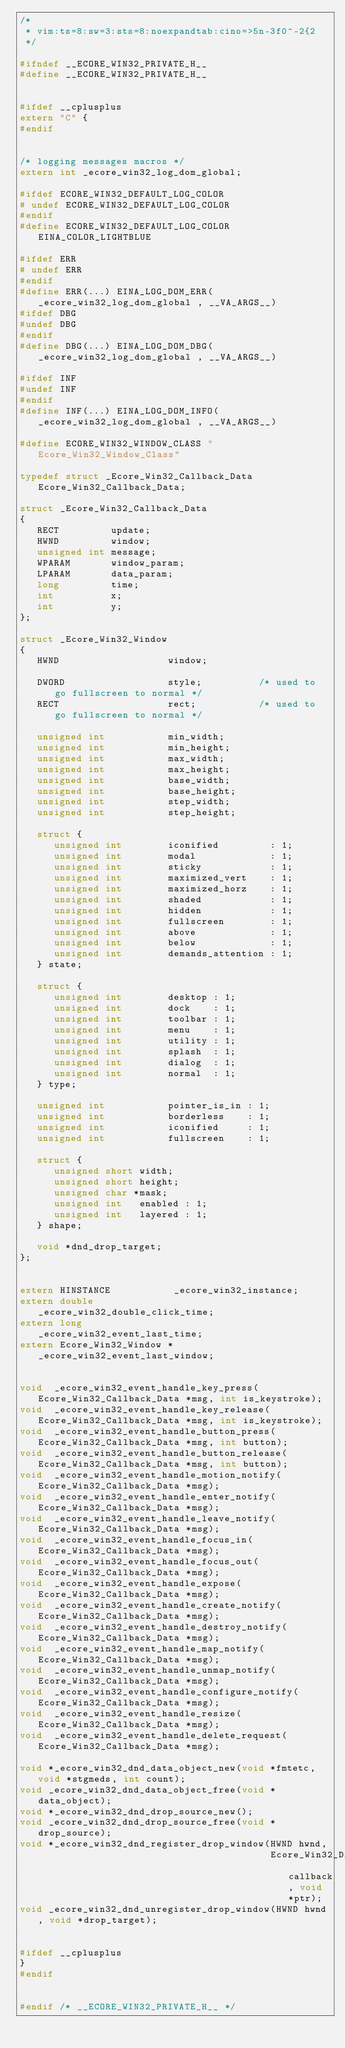<code> <loc_0><loc_0><loc_500><loc_500><_C_>/*
 * vim:ts=8:sw=3:sts=8:noexpandtab:cino=>5n-3f0^-2{2
 */

#ifndef __ECORE_WIN32_PRIVATE_H__
#define __ECORE_WIN32_PRIVATE_H__


#ifdef __cplusplus
extern "C" {
#endif


/* logging messages macros */
extern int _ecore_win32_log_dom_global;

#ifdef ECORE_WIN32_DEFAULT_LOG_COLOR
# undef ECORE_WIN32_DEFAULT_LOG_COLOR
#endif
#define ECORE_WIN32_DEFAULT_LOG_COLOR EINA_COLOR_LIGHTBLUE

#ifdef ERR
# undef ERR
#endif
#define ERR(...) EINA_LOG_DOM_ERR(_ecore_win32_log_dom_global , __VA_ARGS__)
#ifdef DBG
#undef DBG
#endif
#define DBG(...) EINA_LOG_DOM_DBG(_ecore_win32_log_dom_global , __VA_ARGS__)

#ifdef INF
#undef INF
#endif
#define INF(...) EINA_LOG_DOM_INFO(_ecore_win32_log_dom_global , __VA_ARGS__)

#define ECORE_WIN32_WINDOW_CLASS "Ecore_Win32_Window_Class"

typedef struct _Ecore_Win32_Callback_Data Ecore_Win32_Callback_Data;

struct _Ecore_Win32_Callback_Data
{
   RECT         update;
   HWND         window;
   unsigned int message;
   WPARAM       window_param;
   LPARAM       data_param;
   long         time;
   int          x;
   int          y;
};

struct _Ecore_Win32_Window
{
   HWND                   window;

   DWORD                  style;          /* used to go fullscreen to normal */
   RECT                   rect;           /* used to go fullscreen to normal */

   unsigned int           min_width;
   unsigned int           min_height;
   unsigned int           max_width;
   unsigned int           max_height;
   unsigned int           base_width;
   unsigned int           base_height;
   unsigned int           step_width;
   unsigned int           step_height;

   struct {
      unsigned int        iconified         : 1;
      unsigned int        modal             : 1;
      unsigned int        sticky            : 1;
      unsigned int        maximized_vert    : 1;
      unsigned int        maximized_horz    : 1;
      unsigned int        shaded            : 1;
      unsigned int        hidden            : 1;
      unsigned int        fullscreen        : 1;
      unsigned int        above             : 1;
      unsigned int        below             : 1;
      unsigned int        demands_attention : 1;
   } state;

   struct {
      unsigned int        desktop : 1;
      unsigned int        dock    : 1;
      unsigned int        toolbar : 1;
      unsigned int        menu    : 1;
      unsigned int        utility : 1;
      unsigned int        splash  : 1;
      unsigned int        dialog  : 1;
      unsigned int        normal  : 1;
   } type;

   unsigned int           pointer_is_in : 1;
   unsigned int           borderless    : 1;
   unsigned int           iconified     : 1;
   unsigned int           fullscreen    : 1;

   struct {
      unsigned short width;
      unsigned short height;
      unsigned char *mask;
      unsigned int   enabled : 1;
      unsigned int   layered : 1;
   } shape;

   void *dnd_drop_target;
};


extern HINSTANCE           _ecore_win32_instance;
extern double              _ecore_win32_double_click_time;
extern long                _ecore_win32_event_last_time;
extern Ecore_Win32_Window *_ecore_win32_event_last_window;


void  _ecore_win32_event_handle_key_press(Ecore_Win32_Callback_Data *msg, int is_keystroke);
void  _ecore_win32_event_handle_key_release(Ecore_Win32_Callback_Data *msg, int is_keystroke);
void  _ecore_win32_event_handle_button_press(Ecore_Win32_Callback_Data *msg, int button);
void  _ecore_win32_event_handle_button_release(Ecore_Win32_Callback_Data *msg, int button);
void  _ecore_win32_event_handle_motion_notify(Ecore_Win32_Callback_Data *msg);
void  _ecore_win32_event_handle_enter_notify(Ecore_Win32_Callback_Data *msg);
void  _ecore_win32_event_handle_leave_notify(Ecore_Win32_Callback_Data *msg);
void  _ecore_win32_event_handle_focus_in(Ecore_Win32_Callback_Data *msg);
void  _ecore_win32_event_handle_focus_out(Ecore_Win32_Callback_Data *msg);
void  _ecore_win32_event_handle_expose(Ecore_Win32_Callback_Data *msg);
void  _ecore_win32_event_handle_create_notify(Ecore_Win32_Callback_Data *msg);
void  _ecore_win32_event_handle_destroy_notify(Ecore_Win32_Callback_Data *msg);
void  _ecore_win32_event_handle_map_notify(Ecore_Win32_Callback_Data *msg);
void  _ecore_win32_event_handle_unmap_notify(Ecore_Win32_Callback_Data *msg);
void  _ecore_win32_event_handle_configure_notify(Ecore_Win32_Callback_Data *msg);
void  _ecore_win32_event_handle_resize(Ecore_Win32_Callback_Data *msg);
void  _ecore_win32_event_handle_delete_request(Ecore_Win32_Callback_Data *msg);

void *_ecore_win32_dnd_data_object_new(void *fmtetc, void *stgmeds, int count);
void _ecore_win32_dnd_data_object_free(void *data_object);
void *_ecore_win32_dnd_drop_source_new();
void _ecore_win32_dnd_drop_source_free(void *drop_source);
void *_ecore_win32_dnd_register_drop_window(HWND hwnd,
                                            Ecore_Win32_Dnd_DropTarget_Callback callback, void *ptr);
void _ecore_win32_dnd_unregister_drop_window(HWND hwnd, void *drop_target);


#ifdef __cplusplus
}
#endif


#endif /* __ECORE_WIN32_PRIVATE_H__ */
</code> 